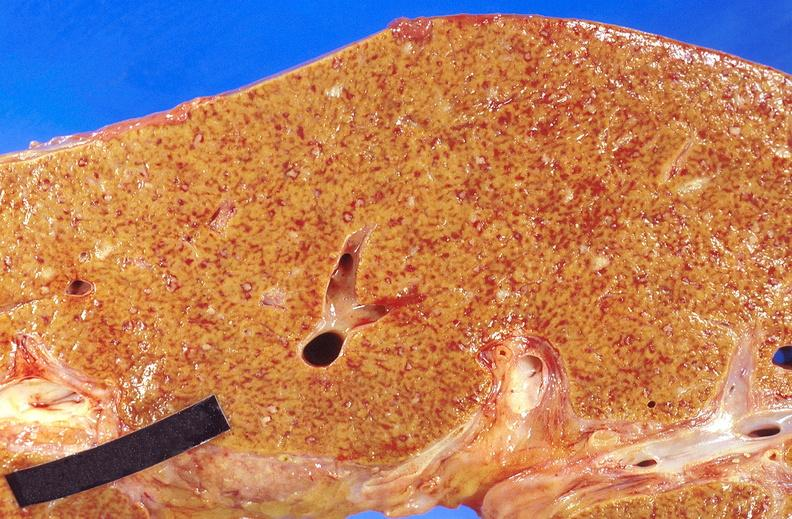what does this image show?
Answer the question using a single word or phrase. Liver 